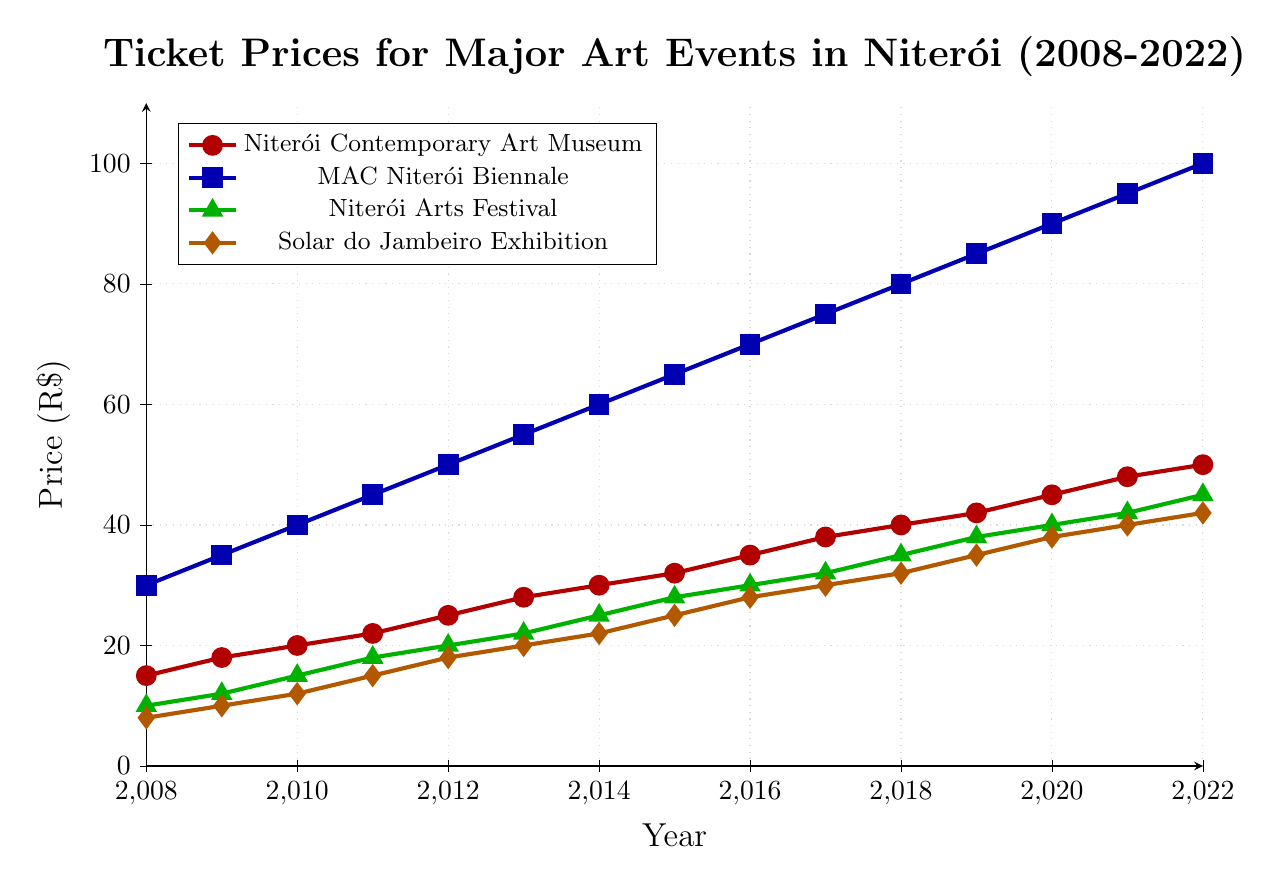What was the price of the Niterói Contemporary Art Museum ticket in 2012? To find the price in 2012, locate the corresponding line (red) for Niterói Contemporary Art Museum in the year 2012. The value is 25.
Answer: 25 How much did the ticket price for the MAC Niterói Biennale increase from 2008 to 2022? Find the difference between the ticket prices in 2022 and 2008 on the blue line for MAC Niterói Biennale: 100 (2022) - 30 (2008) = 70.
Answer: 70 In which year did the Solar do Jambeiro Exhibition ticket price reach 30? Locate the point on the orange line where the value reaches 30. This occurs in the year 2017.
Answer: 2017 Compare the ticket price of Niterói Arts Festival in 2010 and MAC Niterói Biennale in 2010. Which one is higher, and by how much? For Niterói Arts Festival (green line) in 2010, the price is 15. For MAC Niterói Biennale (blue line) in 2010, the price is 40. The MAC Niterói Biennale price is higher by 40 - 15 = 25.
Answer: MAC Niterói Biennale, by 25 What is the average ticket price of all four events in 2020? Sum the ticket prices in 2020 for all four events and divide by 4: (45 + 90 + 40 + 38) / 4 = 213 / 4 = 53.25.
Answer: 53.25 Between 2008 and 2022, which event had the smallest increase in ticket price? Calculate the price increase for each event from 2008 to 2022: Niterói Contemporary Art Museum: 50-15=35, MAC Niterói Biennale: 100-30=70, Niterói Arts Festival: 45-10=35, Solar do Jambeiro Exhibition: 42-8=34. The smallest increase is for the Solar do Jambeiro Exhibition with 34.
Answer: Solar do Jambeiro Exhibition In which year did the ticket price for the Niterói Contemporary Art Museum surpass 30? Find the first year where the red line for Niterói Contemporary Art Museum crosses the 30 mark. This occurs in 2014.
Answer: 2014 What is the combined ticket price for Niterói Contemporary Art Museum and Niterói Arts Festival in 2015? Sum the ticket prices for Niterói Contemporary Art Museum (32) and Niterói Arts Festival (28) in 2015: 32 + 28 = 60.
Answer: 60 Is there any year where the ticket prices for all four events are equal? Visually inspect the graph to see if all four lines intersect at the same point. No such intersection is observed.
Answer: No 